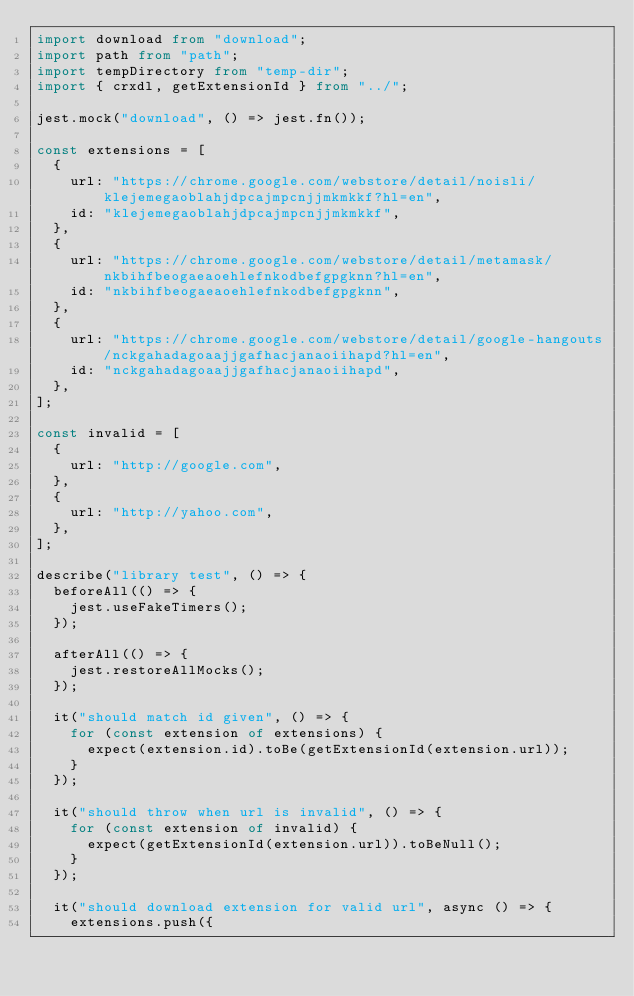<code> <loc_0><loc_0><loc_500><loc_500><_TypeScript_>import download from "download";
import path from "path";
import tempDirectory from "temp-dir";
import { crxdl, getExtensionId } from "../";

jest.mock("download", () => jest.fn());

const extensions = [
	{
		url: "https://chrome.google.com/webstore/detail/noisli/klejemegaoblahjdpcajmpcnjjmkmkkf?hl=en",
		id: "klejemegaoblahjdpcajmpcnjjmkmkkf",
	},
	{
		url: "https://chrome.google.com/webstore/detail/metamask/nkbihfbeogaeaoehlefnkodbefgpgknn?hl=en",
		id: "nkbihfbeogaeaoehlefnkodbefgpgknn",
	},
	{
		url: "https://chrome.google.com/webstore/detail/google-hangouts/nckgahadagoaajjgafhacjanaoiihapd?hl=en",
		id: "nckgahadagoaajjgafhacjanaoiihapd",
	},
];

const invalid = [
	{
		url: "http://google.com",
	},
	{
		url: "http://yahoo.com",
	},
];

describe("library test", () => {
	beforeAll(() => {
		jest.useFakeTimers();
	});

	afterAll(() => {
		jest.restoreAllMocks();
	});

	it("should match id given", () => {
		for (const extension of extensions) {
			expect(extension.id).toBe(getExtensionId(extension.url));
		}
	});

	it("should throw when url is invalid", () => {
		for (const extension of invalid) {
			expect(getExtensionId(extension.url)).toBeNull();
		}
	});

	it("should download extension for valid url", async () => {
		extensions.push({</code> 